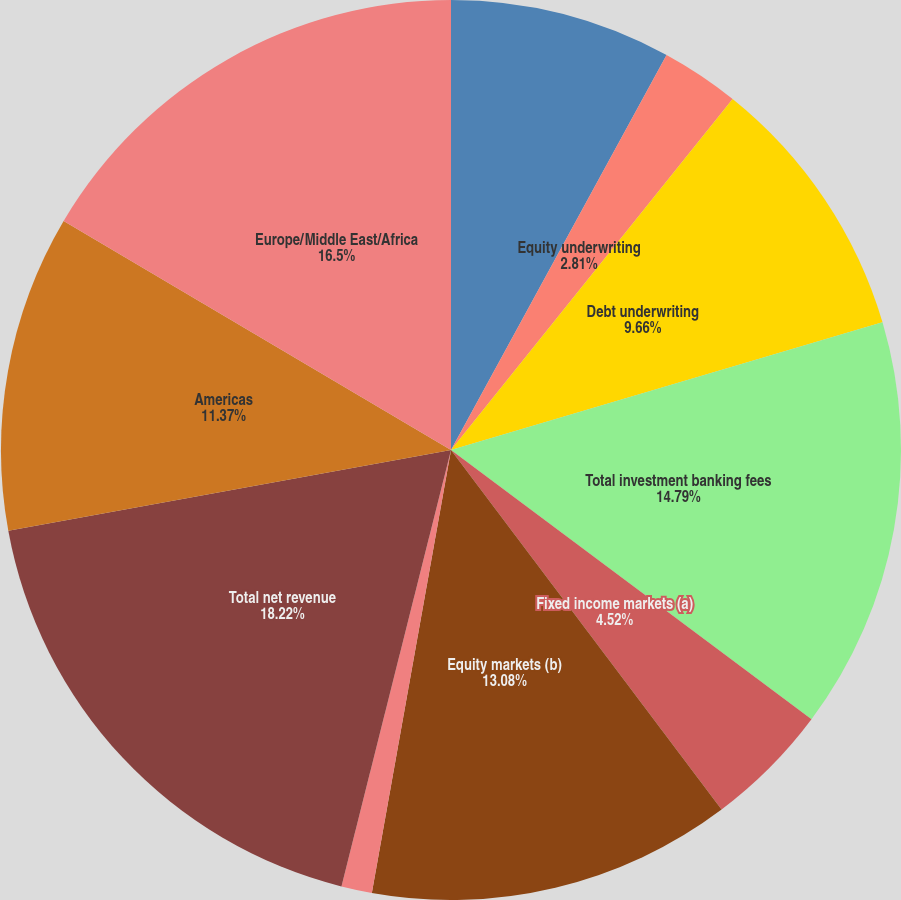Convert chart. <chart><loc_0><loc_0><loc_500><loc_500><pie_chart><fcel>Advisory<fcel>Equity underwriting<fcel>Debt underwriting<fcel>Total investment banking fees<fcel>Fixed income markets (a)<fcel>Equity markets (b)<fcel>Credit portfolio (c)<fcel>Total net revenue<fcel>Americas<fcel>Europe/Middle East/Africa<nl><fcel>7.95%<fcel>2.81%<fcel>9.66%<fcel>14.79%<fcel>4.52%<fcel>13.08%<fcel>1.1%<fcel>18.21%<fcel>11.37%<fcel>16.5%<nl></chart> 